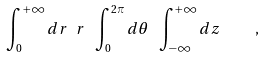Convert formula to latex. <formula><loc_0><loc_0><loc_500><loc_500>\int _ { 0 } ^ { + \infty } d r \ r \ \int _ { 0 } ^ { 2 \pi } d \theta \ \int _ { - \infty } ^ { + \infty } d z \quad ,</formula> 